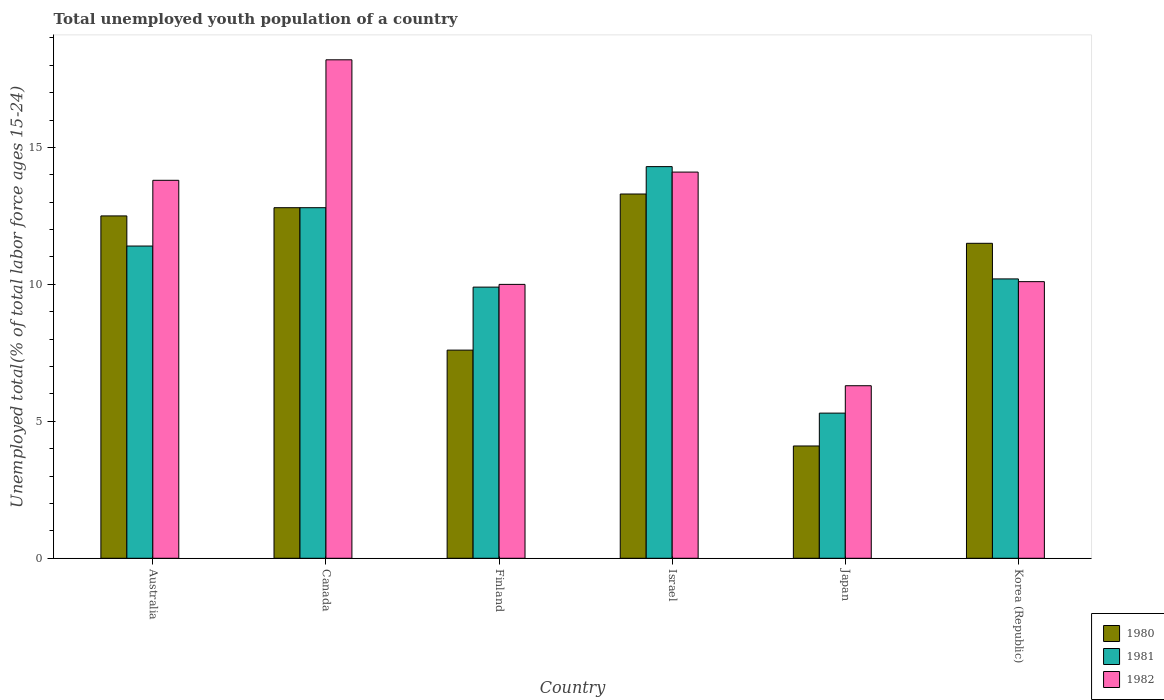How many different coloured bars are there?
Your response must be concise. 3. How many groups of bars are there?
Your answer should be very brief. 6. Are the number of bars on each tick of the X-axis equal?
Keep it short and to the point. Yes. What is the label of the 1st group of bars from the left?
Your response must be concise. Australia. In how many cases, is the number of bars for a given country not equal to the number of legend labels?
Keep it short and to the point. 0. What is the percentage of total unemployed youth population of a country in 1981 in Israel?
Your answer should be very brief. 14.3. Across all countries, what is the maximum percentage of total unemployed youth population of a country in 1981?
Ensure brevity in your answer.  14.3. Across all countries, what is the minimum percentage of total unemployed youth population of a country in 1980?
Provide a short and direct response. 4.1. What is the total percentage of total unemployed youth population of a country in 1982 in the graph?
Your answer should be compact. 72.5. What is the difference between the percentage of total unemployed youth population of a country in 1980 in Finland and that in Korea (Republic)?
Your answer should be compact. -3.9. What is the difference between the percentage of total unemployed youth population of a country in 1982 in Canada and the percentage of total unemployed youth population of a country in 1981 in Finland?
Keep it short and to the point. 8.3. What is the average percentage of total unemployed youth population of a country in 1981 per country?
Give a very brief answer. 10.65. What is the difference between the percentage of total unemployed youth population of a country of/in 1981 and percentage of total unemployed youth population of a country of/in 1982 in Canada?
Keep it short and to the point. -5.4. What is the ratio of the percentage of total unemployed youth population of a country in 1982 in Australia to that in Korea (Republic)?
Ensure brevity in your answer.  1.37. Is the difference between the percentage of total unemployed youth population of a country in 1981 in Canada and Japan greater than the difference between the percentage of total unemployed youth population of a country in 1982 in Canada and Japan?
Your answer should be very brief. No. What is the difference between the highest and the second highest percentage of total unemployed youth population of a country in 1980?
Your answer should be very brief. -0.3. What is the difference between the highest and the lowest percentage of total unemployed youth population of a country in 1981?
Make the answer very short. 9. In how many countries, is the percentage of total unemployed youth population of a country in 1980 greater than the average percentage of total unemployed youth population of a country in 1980 taken over all countries?
Offer a very short reply. 4. What does the 2nd bar from the right in Australia represents?
Offer a very short reply. 1981. Are all the bars in the graph horizontal?
Provide a succinct answer. No. What is the difference between two consecutive major ticks on the Y-axis?
Offer a terse response. 5. Are the values on the major ticks of Y-axis written in scientific E-notation?
Your answer should be compact. No. Does the graph contain grids?
Make the answer very short. No. How many legend labels are there?
Your answer should be very brief. 3. How are the legend labels stacked?
Give a very brief answer. Vertical. What is the title of the graph?
Your answer should be very brief. Total unemployed youth population of a country. What is the label or title of the Y-axis?
Provide a succinct answer. Unemployed total(% of total labor force ages 15-24). What is the Unemployed total(% of total labor force ages 15-24) in 1981 in Australia?
Keep it short and to the point. 11.4. What is the Unemployed total(% of total labor force ages 15-24) of 1982 in Australia?
Your answer should be very brief. 13.8. What is the Unemployed total(% of total labor force ages 15-24) of 1980 in Canada?
Offer a terse response. 12.8. What is the Unemployed total(% of total labor force ages 15-24) of 1981 in Canada?
Offer a very short reply. 12.8. What is the Unemployed total(% of total labor force ages 15-24) of 1982 in Canada?
Keep it short and to the point. 18.2. What is the Unemployed total(% of total labor force ages 15-24) in 1980 in Finland?
Make the answer very short. 7.6. What is the Unemployed total(% of total labor force ages 15-24) in 1981 in Finland?
Make the answer very short. 9.9. What is the Unemployed total(% of total labor force ages 15-24) of 1982 in Finland?
Keep it short and to the point. 10. What is the Unemployed total(% of total labor force ages 15-24) of 1980 in Israel?
Ensure brevity in your answer.  13.3. What is the Unemployed total(% of total labor force ages 15-24) in 1981 in Israel?
Ensure brevity in your answer.  14.3. What is the Unemployed total(% of total labor force ages 15-24) in 1982 in Israel?
Keep it short and to the point. 14.1. What is the Unemployed total(% of total labor force ages 15-24) of 1980 in Japan?
Provide a succinct answer. 4.1. What is the Unemployed total(% of total labor force ages 15-24) in 1981 in Japan?
Offer a terse response. 5.3. What is the Unemployed total(% of total labor force ages 15-24) in 1982 in Japan?
Give a very brief answer. 6.3. What is the Unemployed total(% of total labor force ages 15-24) in 1981 in Korea (Republic)?
Provide a succinct answer. 10.2. What is the Unemployed total(% of total labor force ages 15-24) of 1982 in Korea (Republic)?
Keep it short and to the point. 10.1. Across all countries, what is the maximum Unemployed total(% of total labor force ages 15-24) of 1980?
Ensure brevity in your answer.  13.3. Across all countries, what is the maximum Unemployed total(% of total labor force ages 15-24) of 1981?
Keep it short and to the point. 14.3. Across all countries, what is the maximum Unemployed total(% of total labor force ages 15-24) in 1982?
Offer a terse response. 18.2. Across all countries, what is the minimum Unemployed total(% of total labor force ages 15-24) in 1980?
Your response must be concise. 4.1. Across all countries, what is the minimum Unemployed total(% of total labor force ages 15-24) of 1981?
Offer a terse response. 5.3. Across all countries, what is the minimum Unemployed total(% of total labor force ages 15-24) in 1982?
Provide a succinct answer. 6.3. What is the total Unemployed total(% of total labor force ages 15-24) of 1980 in the graph?
Your response must be concise. 61.8. What is the total Unemployed total(% of total labor force ages 15-24) of 1981 in the graph?
Your answer should be compact. 63.9. What is the total Unemployed total(% of total labor force ages 15-24) in 1982 in the graph?
Keep it short and to the point. 72.5. What is the difference between the Unemployed total(% of total labor force ages 15-24) of 1981 in Australia and that in Canada?
Ensure brevity in your answer.  -1.4. What is the difference between the Unemployed total(% of total labor force ages 15-24) of 1981 in Australia and that in Finland?
Provide a succinct answer. 1.5. What is the difference between the Unemployed total(% of total labor force ages 15-24) of 1980 in Australia and that in Japan?
Your response must be concise. 8.4. What is the difference between the Unemployed total(% of total labor force ages 15-24) of 1981 in Australia and that in Japan?
Provide a short and direct response. 6.1. What is the difference between the Unemployed total(% of total labor force ages 15-24) in 1982 in Australia and that in Japan?
Provide a short and direct response. 7.5. What is the difference between the Unemployed total(% of total labor force ages 15-24) in 1981 in Australia and that in Korea (Republic)?
Offer a terse response. 1.2. What is the difference between the Unemployed total(% of total labor force ages 15-24) of 1980 in Canada and that in Finland?
Give a very brief answer. 5.2. What is the difference between the Unemployed total(% of total labor force ages 15-24) of 1980 in Canada and that in Japan?
Keep it short and to the point. 8.7. What is the difference between the Unemployed total(% of total labor force ages 15-24) of 1981 in Canada and that in Japan?
Your answer should be compact. 7.5. What is the difference between the Unemployed total(% of total labor force ages 15-24) of 1980 in Canada and that in Korea (Republic)?
Keep it short and to the point. 1.3. What is the difference between the Unemployed total(% of total labor force ages 15-24) in 1981 in Canada and that in Korea (Republic)?
Make the answer very short. 2.6. What is the difference between the Unemployed total(% of total labor force ages 15-24) in 1980 in Finland and that in Israel?
Make the answer very short. -5.7. What is the difference between the Unemployed total(% of total labor force ages 15-24) in 1981 in Finland and that in Israel?
Your response must be concise. -4.4. What is the difference between the Unemployed total(% of total labor force ages 15-24) of 1982 in Finland and that in Israel?
Provide a succinct answer. -4.1. What is the difference between the Unemployed total(% of total labor force ages 15-24) of 1980 in Finland and that in Japan?
Your response must be concise. 3.5. What is the difference between the Unemployed total(% of total labor force ages 15-24) in 1981 in Finland and that in Japan?
Offer a very short reply. 4.6. What is the difference between the Unemployed total(% of total labor force ages 15-24) of 1982 in Finland and that in Japan?
Ensure brevity in your answer.  3.7. What is the difference between the Unemployed total(% of total labor force ages 15-24) of 1982 in Finland and that in Korea (Republic)?
Offer a very short reply. -0.1. What is the difference between the Unemployed total(% of total labor force ages 15-24) of 1980 in Israel and that in Japan?
Keep it short and to the point. 9.2. What is the difference between the Unemployed total(% of total labor force ages 15-24) of 1980 in Israel and that in Korea (Republic)?
Ensure brevity in your answer.  1.8. What is the difference between the Unemployed total(% of total labor force ages 15-24) of 1981 in Israel and that in Korea (Republic)?
Your answer should be very brief. 4.1. What is the difference between the Unemployed total(% of total labor force ages 15-24) in 1982 in Israel and that in Korea (Republic)?
Provide a short and direct response. 4. What is the difference between the Unemployed total(% of total labor force ages 15-24) of 1981 in Japan and that in Korea (Republic)?
Your answer should be very brief. -4.9. What is the difference between the Unemployed total(% of total labor force ages 15-24) of 1982 in Japan and that in Korea (Republic)?
Keep it short and to the point. -3.8. What is the difference between the Unemployed total(% of total labor force ages 15-24) of 1980 in Australia and the Unemployed total(% of total labor force ages 15-24) of 1981 in Canada?
Provide a short and direct response. -0.3. What is the difference between the Unemployed total(% of total labor force ages 15-24) of 1981 in Australia and the Unemployed total(% of total labor force ages 15-24) of 1982 in Canada?
Make the answer very short. -6.8. What is the difference between the Unemployed total(% of total labor force ages 15-24) in 1980 in Australia and the Unemployed total(% of total labor force ages 15-24) in 1982 in Finland?
Give a very brief answer. 2.5. What is the difference between the Unemployed total(% of total labor force ages 15-24) of 1980 in Australia and the Unemployed total(% of total labor force ages 15-24) of 1982 in Israel?
Provide a short and direct response. -1.6. What is the difference between the Unemployed total(% of total labor force ages 15-24) of 1981 in Australia and the Unemployed total(% of total labor force ages 15-24) of 1982 in Israel?
Offer a very short reply. -2.7. What is the difference between the Unemployed total(% of total labor force ages 15-24) in 1980 in Australia and the Unemployed total(% of total labor force ages 15-24) in 1981 in Japan?
Offer a terse response. 7.2. What is the difference between the Unemployed total(% of total labor force ages 15-24) in 1981 in Australia and the Unemployed total(% of total labor force ages 15-24) in 1982 in Japan?
Your response must be concise. 5.1. What is the difference between the Unemployed total(% of total labor force ages 15-24) in 1980 in Australia and the Unemployed total(% of total labor force ages 15-24) in 1981 in Korea (Republic)?
Offer a terse response. 2.3. What is the difference between the Unemployed total(% of total labor force ages 15-24) in 1981 in Australia and the Unemployed total(% of total labor force ages 15-24) in 1982 in Korea (Republic)?
Your answer should be compact. 1.3. What is the difference between the Unemployed total(% of total labor force ages 15-24) in 1980 in Canada and the Unemployed total(% of total labor force ages 15-24) in 1982 in Finland?
Provide a succinct answer. 2.8. What is the difference between the Unemployed total(% of total labor force ages 15-24) of 1980 in Canada and the Unemployed total(% of total labor force ages 15-24) of 1982 in Israel?
Provide a short and direct response. -1.3. What is the difference between the Unemployed total(% of total labor force ages 15-24) in 1981 in Canada and the Unemployed total(% of total labor force ages 15-24) in 1982 in Japan?
Your response must be concise. 6.5. What is the difference between the Unemployed total(% of total labor force ages 15-24) of 1980 in Canada and the Unemployed total(% of total labor force ages 15-24) of 1981 in Korea (Republic)?
Your answer should be very brief. 2.6. What is the difference between the Unemployed total(% of total labor force ages 15-24) of 1980 in Canada and the Unemployed total(% of total labor force ages 15-24) of 1982 in Korea (Republic)?
Provide a short and direct response. 2.7. What is the difference between the Unemployed total(% of total labor force ages 15-24) of 1980 in Finland and the Unemployed total(% of total labor force ages 15-24) of 1981 in Israel?
Give a very brief answer. -6.7. What is the difference between the Unemployed total(% of total labor force ages 15-24) of 1980 in Finland and the Unemployed total(% of total labor force ages 15-24) of 1982 in Israel?
Offer a very short reply. -6.5. What is the difference between the Unemployed total(% of total labor force ages 15-24) in 1981 in Finland and the Unemployed total(% of total labor force ages 15-24) in 1982 in Israel?
Keep it short and to the point. -4.2. What is the difference between the Unemployed total(% of total labor force ages 15-24) in 1980 in Finland and the Unemployed total(% of total labor force ages 15-24) in 1981 in Korea (Republic)?
Your answer should be compact. -2.6. What is the difference between the Unemployed total(% of total labor force ages 15-24) in 1980 in Finland and the Unemployed total(% of total labor force ages 15-24) in 1982 in Korea (Republic)?
Your answer should be compact. -2.5. What is the difference between the Unemployed total(% of total labor force ages 15-24) of 1981 in Finland and the Unemployed total(% of total labor force ages 15-24) of 1982 in Korea (Republic)?
Offer a very short reply. -0.2. What is the difference between the Unemployed total(% of total labor force ages 15-24) in 1980 in Israel and the Unemployed total(% of total labor force ages 15-24) in 1981 in Japan?
Your answer should be very brief. 8. What is the difference between the Unemployed total(% of total labor force ages 15-24) of 1980 in Israel and the Unemployed total(% of total labor force ages 15-24) of 1982 in Japan?
Offer a terse response. 7. What is the difference between the Unemployed total(% of total labor force ages 15-24) of 1981 in Israel and the Unemployed total(% of total labor force ages 15-24) of 1982 in Japan?
Offer a very short reply. 8. What is the difference between the Unemployed total(% of total labor force ages 15-24) of 1981 in Israel and the Unemployed total(% of total labor force ages 15-24) of 1982 in Korea (Republic)?
Make the answer very short. 4.2. What is the difference between the Unemployed total(% of total labor force ages 15-24) in 1981 in Japan and the Unemployed total(% of total labor force ages 15-24) in 1982 in Korea (Republic)?
Make the answer very short. -4.8. What is the average Unemployed total(% of total labor force ages 15-24) in 1981 per country?
Make the answer very short. 10.65. What is the average Unemployed total(% of total labor force ages 15-24) of 1982 per country?
Ensure brevity in your answer.  12.08. What is the difference between the Unemployed total(% of total labor force ages 15-24) of 1980 and Unemployed total(% of total labor force ages 15-24) of 1982 in Australia?
Provide a short and direct response. -1.3. What is the difference between the Unemployed total(% of total labor force ages 15-24) of 1981 and Unemployed total(% of total labor force ages 15-24) of 1982 in Australia?
Make the answer very short. -2.4. What is the difference between the Unemployed total(% of total labor force ages 15-24) in 1980 and Unemployed total(% of total labor force ages 15-24) in 1982 in Canada?
Your answer should be compact. -5.4. What is the difference between the Unemployed total(% of total labor force ages 15-24) of 1981 and Unemployed total(% of total labor force ages 15-24) of 1982 in Canada?
Make the answer very short. -5.4. What is the difference between the Unemployed total(% of total labor force ages 15-24) in 1980 and Unemployed total(% of total labor force ages 15-24) in 1982 in Finland?
Give a very brief answer. -2.4. What is the difference between the Unemployed total(% of total labor force ages 15-24) in 1980 and Unemployed total(% of total labor force ages 15-24) in 1981 in Israel?
Offer a very short reply. -1. What is the difference between the Unemployed total(% of total labor force ages 15-24) of 1981 and Unemployed total(% of total labor force ages 15-24) of 1982 in Israel?
Your answer should be very brief. 0.2. What is the difference between the Unemployed total(% of total labor force ages 15-24) in 1980 and Unemployed total(% of total labor force ages 15-24) in 1981 in Korea (Republic)?
Your answer should be very brief. 1.3. What is the ratio of the Unemployed total(% of total labor force ages 15-24) of 1980 in Australia to that in Canada?
Provide a succinct answer. 0.98. What is the ratio of the Unemployed total(% of total labor force ages 15-24) in 1981 in Australia to that in Canada?
Offer a very short reply. 0.89. What is the ratio of the Unemployed total(% of total labor force ages 15-24) in 1982 in Australia to that in Canada?
Your response must be concise. 0.76. What is the ratio of the Unemployed total(% of total labor force ages 15-24) in 1980 in Australia to that in Finland?
Provide a succinct answer. 1.64. What is the ratio of the Unemployed total(% of total labor force ages 15-24) in 1981 in Australia to that in Finland?
Your answer should be very brief. 1.15. What is the ratio of the Unemployed total(% of total labor force ages 15-24) of 1982 in Australia to that in Finland?
Provide a short and direct response. 1.38. What is the ratio of the Unemployed total(% of total labor force ages 15-24) in 1980 in Australia to that in Israel?
Keep it short and to the point. 0.94. What is the ratio of the Unemployed total(% of total labor force ages 15-24) of 1981 in Australia to that in Israel?
Your answer should be compact. 0.8. What is the ratio of the Unemployed total(% of total labor force ages 15-24) of 1982 in Australia to that in Israel?
Provide a short and direct response. 0.98. What is the ratio of the Unemployed total(% of total labor force ages 15-24) of 1980 in Australia to that in Japan?
Give a very brief answer. 3.05. What is the ratio of the Unemployed total(% of total labor force ages 15-24) in 1981 in Australia to that in Japan?
Ensure brevity in your answer.  2.15. What is the ratio of the Unemployed total(% of total labor force ages 15-24) in 1982 in Australia to that in Japan?
Offer a terse response. 2.19. What is the ratio of the Unemployed total(% of total labor force ages 15-24) in 1980 in Australia to that in Korea (Republic)?
Your answer should be very brief. 1.09. What is the ratio of the Unemployed total(% of total labor force ages 15-24) in 1981 in Australia to that in Korea (Republic)?
Provide a succinct answer. 1.12. What is the ratio of the Unemployed total(% of total labor force ages 15-24) in 1982 in Australia to that in Korea (Republic)?
Make the answer very short. 1.37. What is the ratio of the Unemployed total(% of total labor force ages 15-24) in 1980 in Canada to that in Finland?
Make the answer very short. 1.68. What is the ratio of the Unemployed total(% of total labor force ages 15-24) of 1981 in Canada to that in Finland?
Your answer should be compact. 1.29. What is the ratio of the Unemployed total(% of total labor force ages 15-24) in 1982 in Canada to that in Finland?
Ensure brevity in your answer.  1.82. What is the ratio of the Unemployed total(% of total labor force ages 15-24) in 1980 in Canada to that in Israel?
Your answer should be very brief. 0.96. What is the ratio of the Unemployed total(% of total labor force ages 15-24) in 1981 in Canada to that in Israel?
Offer a very short reply. 0.9. What is the ratio of the Unemployed total(% of total labor force ages 15-24) of 1982 in Canada to that in Israel?
Ensure brevity in your answer.  1.29. What is the ratio of the Unemployed total(% of total labor force ages 15-24) in 1980 in Canada to that in Japan?
Make the answer very short. 3.12. What is the ratio of the Unemployed total(% of total labor force ages 15-24) of 1981 in Canada to that in Japan?
Make the answer very short. 2.42. What is the ratio of the Unemployed total(% of total labor force ages 15-24) of 1982 in Canada to that in Japan?
Provide a succinct answer. 2.89. What is the ratio of the Unemployed total(% of total labor force ages 15-24) in 1980 in Canada to that in Korea (Republic)?
Provide a short and direct response. 1.11. What is the ratio of the Unemployed total(% of total labor force ages 15-24) of 1981 in Canada to that in Korea (Republic)?
Provide a short and direct response. 1.25. What is the ratio of the Unemployed total(% of total labor force ages 15-24) in 1982 in Canada to that in Korea (Republic)?
Offer a terse response. 1.8. What is the ratio of the Unemployed total(% of total labor force ages 15-24) in 1981 in Finland to that in Israel?
Offer a very short reply. 0.69. What is the ratio of the Unemployed total(% of total labor force ages 15-24) of 1982 in Finland to that in Israel?
Keep it short and to the point. 0.71. What is the ratio of the Unemployed total(% of total labor force ages 15-24) in 1980 in Finland to that in Japan?
Keep it short and to the point. 1.85. What is the ratio of the Unemployed total(% of total labor force ages 15-24) of 1981 in Finland to that in Japan?
Keep it short and to the point. 1.87. What is the ratio of the Unemployed total(% of total labor force ages 15-24) in 1982 in Finland to that in Japan?
Offer a terse response. 1.59. What is the ratio of the Unemployed total(% of total labor force ages 15-24) in 1980 in Finland to that in Korea (Republic)?
Your answer should be compact. 0.66. What is the ratio of the Unemployed total(% of total labor force ages 15-24) of 1981 in Finland to that in Korea (Republic)?
Your answer should be compact. 0.97. What is the ratio of the Unemployed total(% of total labor force ages 15-24) in 1982 in Finland to that in Korea (Republic)?
Provide a short and direct response. 0.99. What is the ratio of the Unemployed total(% of total labor force ages 15-24) of 1980 in Israel to that in Japan?
Your response must be concise. 3.24. What is the ratio of the Unemployed total(% of total labor force ages 15-24) in 1981 in Israel to that in Japan?
Give a very brief answer. 2.7. What is the ratio of the Unemployed total(% of total labor force ages 15-24) of 1982 in Israel to that in Japan?
Offer a very short reply. 2.24. What is the ratio of the Unemployed total(% of total labor force ages 15-24) in 1980 in Israel to that in Korea (Republic)?
Your response must be concise. 1.16. What is the ratio of the Unemployed total(% of total labor force ages 15-24) in 1981 in Israel to that in Korea (Republic)?
Provide a succinct answer. 1.4. What is the ratio of the Unemployed total(% of total labor force ages 15-24) in 1982 in Israel to that in Korea (Republic)?
Ensure brevity in your answer.  1.4. What is the ratio of the Unemployed total(% of total labor force ages 15-24) in 1980 in Japan to that in Korea (Republic)?
Offer a very short reply. 0.36. What is the ratio of the Unemployed total(% of total labor force ages 15-24) of 1981 in Japan to that in Korea (Republic)?
Your answer should be compact. 0.52. What is the ratio of the Unemployed total(% of total labor force ages 15-24) in 1982 in Japan to that in Korea (Republic)?
Give a very brief answer. 0.62. What is the difference between the highest and the second highest Unemployed total(% of total labor force ages 15-24) in 1981?
Give a very brief answer. 1.5. What is the difference between the highest and the lowest Unemployed total(% of total labor force ages 15-24) in 1980?
Provide a succinct answer. 9.2. 